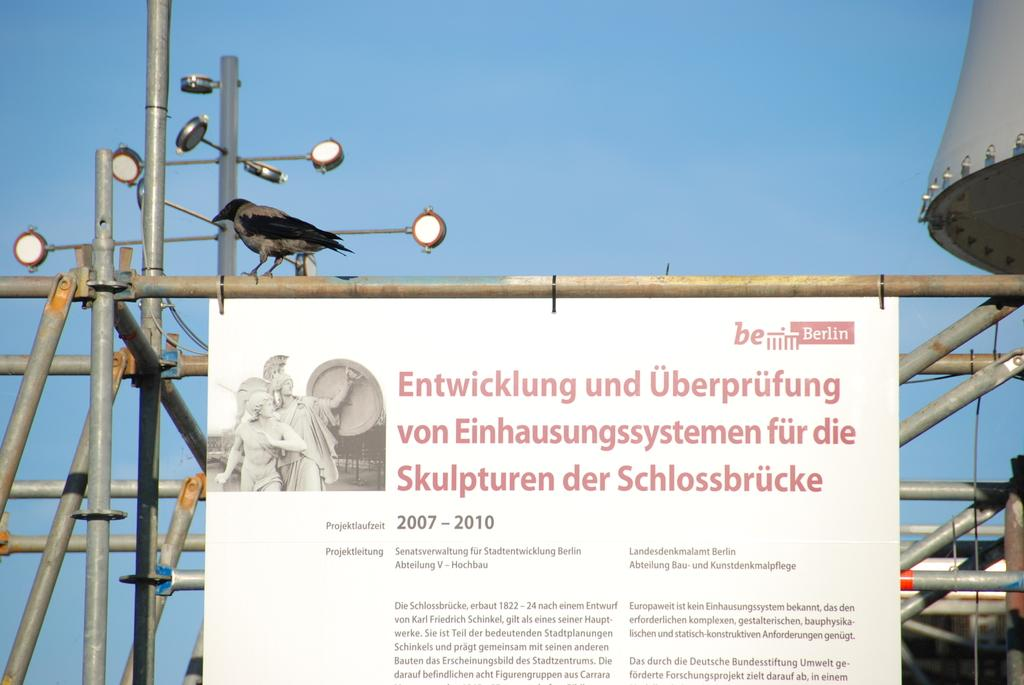<image>
Share a concise interpretation of the image provided. A sign that says the project will take place from 2007 to 2010. 